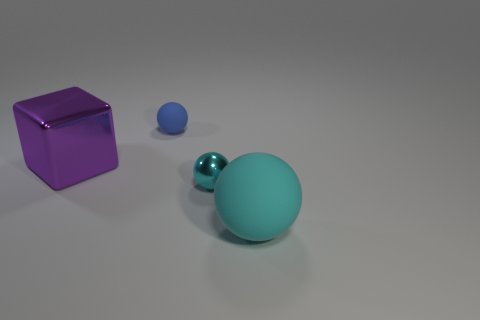Subtract all big cyan matte spheres. How many spheres are left? 2 Add 3 blue things. How many objects exist? 7 Subtract all blue spheres. How many spheres are left? 2 Subtract all purple cylinders. How many cyan balls are left? 2 Subtract 2 spheres. How many spheres are left? 1 Add 1 blue matte balls. How many blue matte balls are left? 2 Add 2 cyan shiny cylinders. How many cyan shiny cylinders exist? 2 Subtract 0 purple spheres. How many objects are left? 4 Subtract all cubes. How many objects are left? 3 Subtract all gray cubes. Subtract all green cylinders. How many cubes are left? 1 